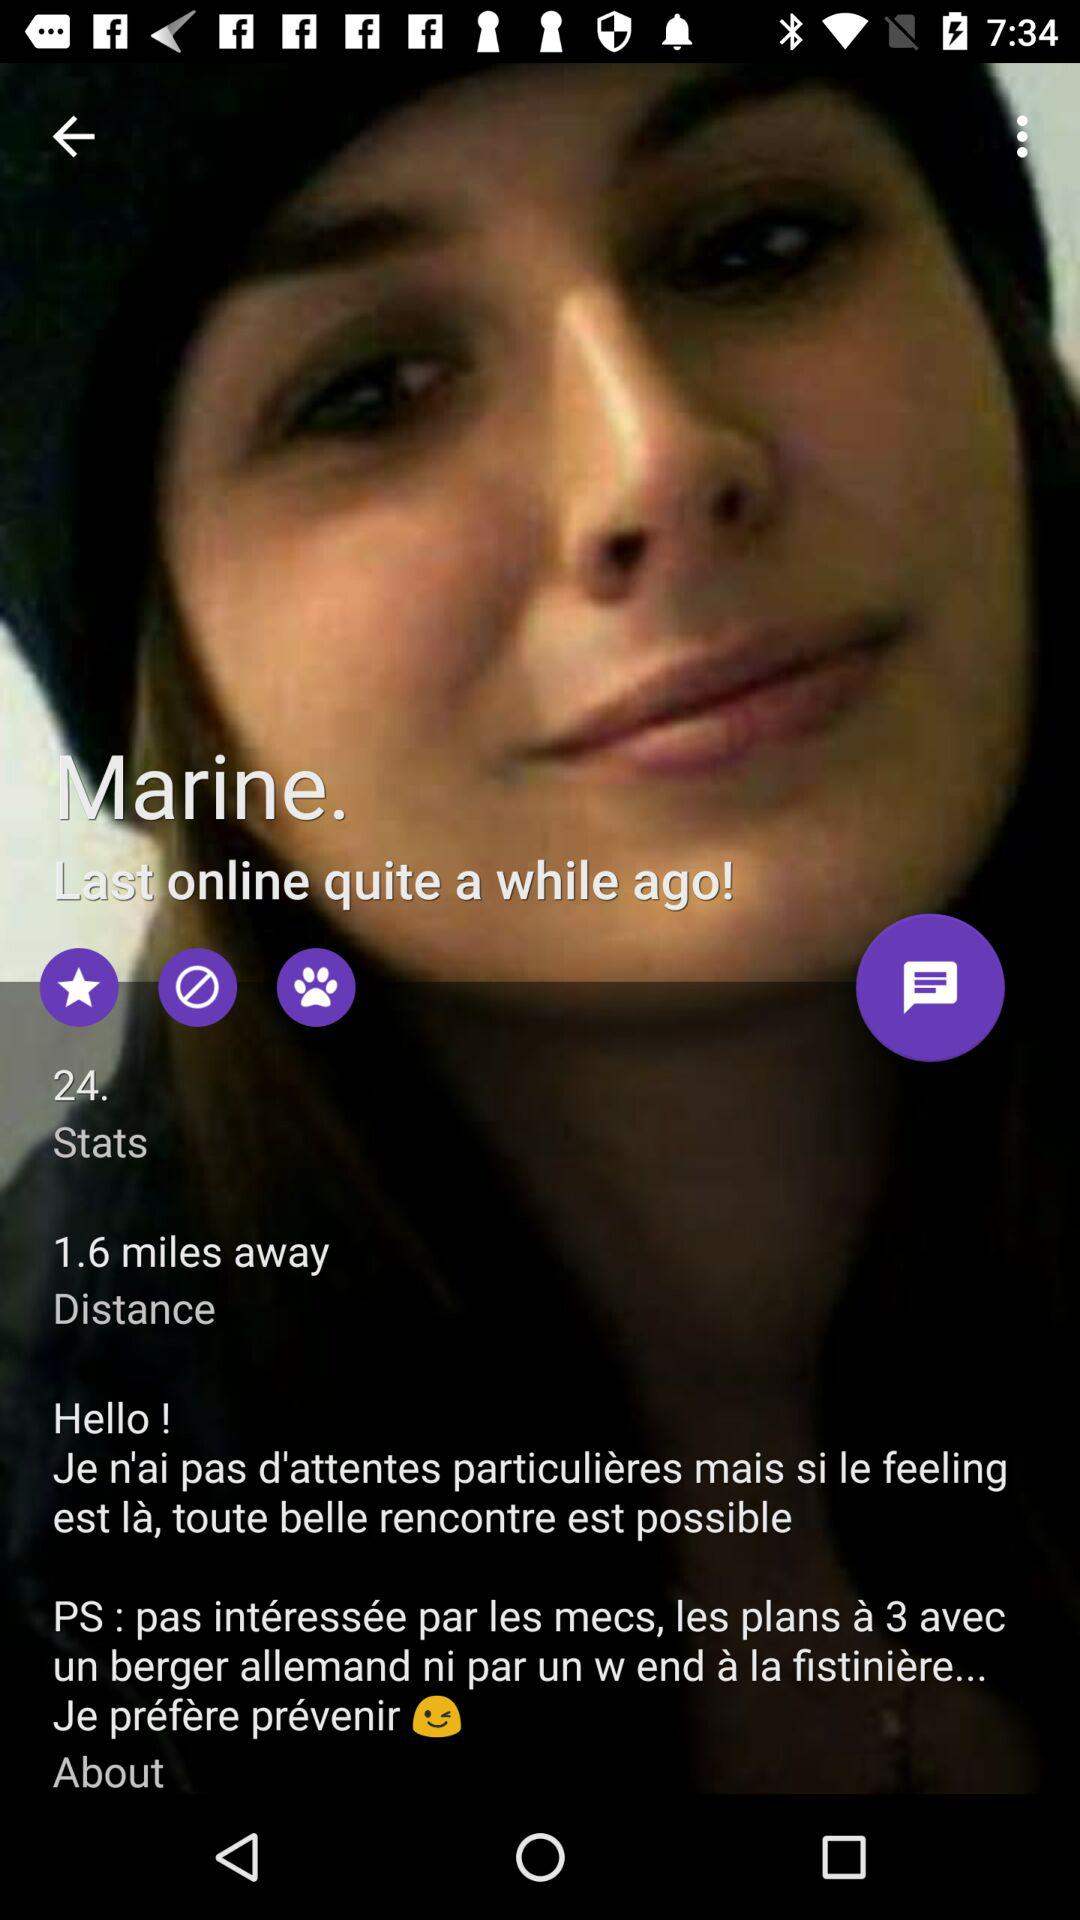What is the name of the user? The name of the user is Marine. 